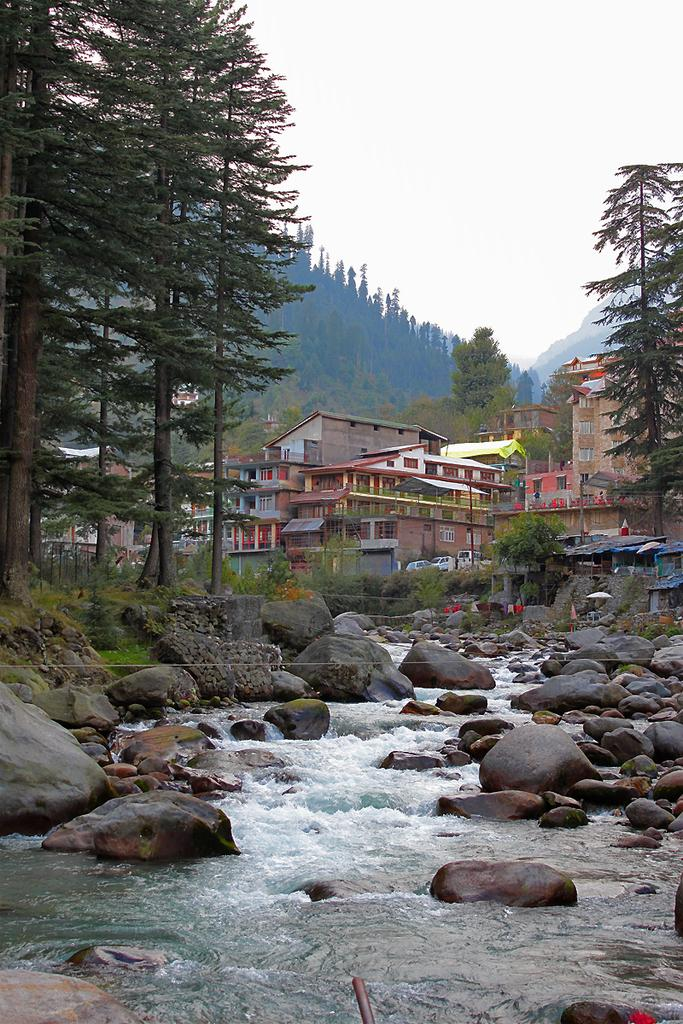What type of structures can be seen in the image? There are buildings in the image. What architectural elements are present in the image? There are walls in the image. What type of vegetation is visible in the image? There are trees in the image. What material is present at the bottom of the image? There are stones at the bottom of the image. What natural feature can be seen at the bottom of the image? Water is flowing at the bottom of the image. What geographical features are visible in the background of the image? There are mountains visible in the background of the image. What part of the natural environment is visible in the background of the image? The sky is visible in the background of the image. Can you tell me how many drains are visible in the image? There are no drains present in the image. What type of sail is attached to the trees in the image? There are no sails present in the image, as it features buildings, walls, trees, stones, flowing water, mountains, and the sky. What type of bulb is illuminating the mountains in the background of the image? There are no bulbs present in the image, and the mountains are not illuminated by any artificial light source. 